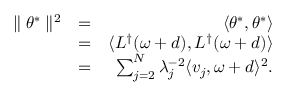<formula> <loc_0><loc_0><loc_500><loc_500>\begin{array} { r l r } { \| \theta ^ { * } \| ^ { 2 } } & { = } & { \langle \theta ^ { * } , \theta ^ { * } \rangle } \\ & { = } & { \langle L ^ { \dagger } ( \omega + d ) , L ^ { \dagger } ( \omega + d ) \rangle } \\ & { = } & { \sum _ { j = 2 } ^ { N } \lambda _ { j } ^ { - 2 } \langle v _ { j } , \omega + d \rangle ^ { 2 } . } \end{array}</formula> 